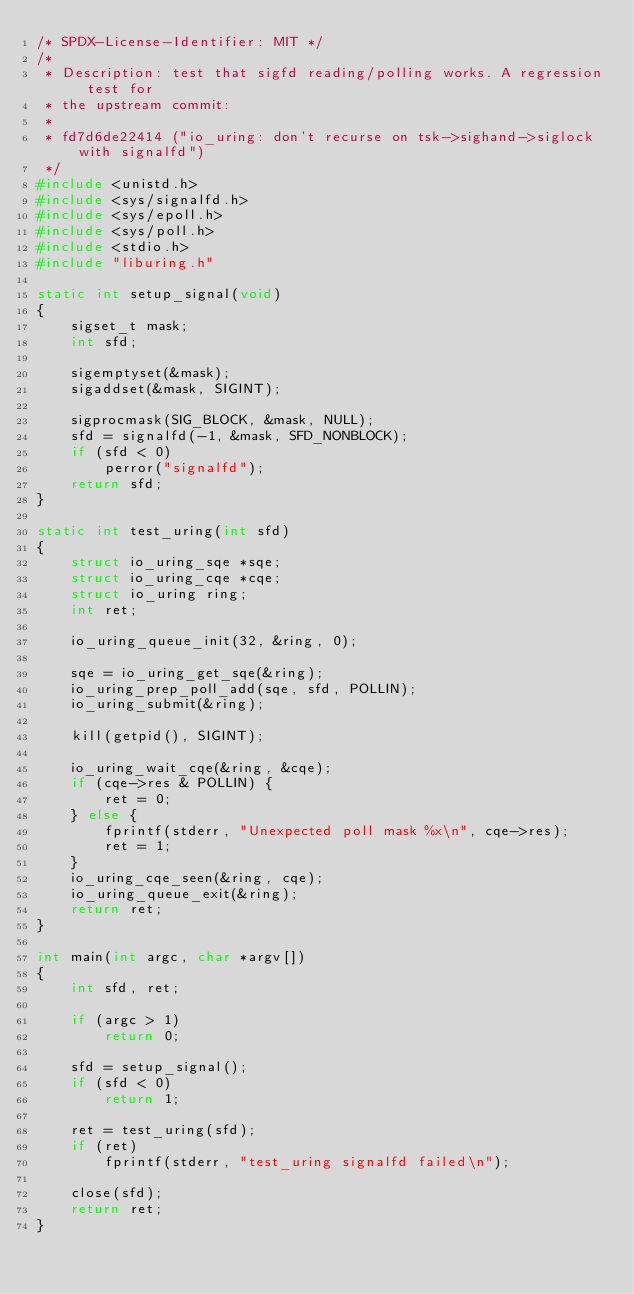<code> <loc_0><loc_0><loc_500><loc_500><_C_>/* SPDX-License-Identifier: MIT */
/*
 * Description: test that sigfd reading/polling works. A regression test for
 * the upstream commit:
 *
 * fd7d6de22414 ("io_uring: don't recurse on tsk->sighand->siglock with signalfd")
 */
#include <unistd.h>
#include <sys/signalfd.h>
#include <sys/epoll.h>
#include <sys/poll.h>
#include <stdio.h>
#include "liburing.h"

static int setup_signal(void)
{
	sigset_t mask;
	int sfd;

	sigemptyset(&mask);
	sigaddset(&mask, SIGINT);

	sigprocmask(SIG_BLOCK, &mask, NULL);
	sfd = signalfd(-1, &mask, SFD_NONBLOCK);
	if (sfd < 0)
		perror("signalfd");
	return sfd;
}

static int test_uring(int sfd)
{
	struct io_uring_sqe *sqe;
	struct io_uring_cqe *cqe;
	struct io_uring ring;
	int ret;

	io_uring_queue_init(32, &ring, 0);

	sqe = io_uring_get_sqe(&ring);
	io_uring_prep_poll_add(sqe, sfd, POLLIN);
	io_uring_submit(&ring);

	kill(getpid(), SIGINT);

	io_uring_wait_cqe(&ring, &cqe);
	if (cqe->res & POLLIN) {
		ret = 0;
	} else {
		fprintf(stderr, "Unexpected poll mask %x\n", cqe->res);
		ret = 1;
	}
	io_uring_cqe_seen(&ring, cqe);
	io_uring_queue_exit(&ring);
	return ret;
}

int main(int argc, char *argv[])
{
	int sfd, ret;

	if (argc > 1)
		return 0;

	sfd = setup_signal();
	if (sfd < 0)
		return 1;

	ret = test_uring(sfd);
	if (ret)
		fprintf(stderr, "test_uring signalfd failed\n");

	close(sfd);
	return ret;
}
</code> 